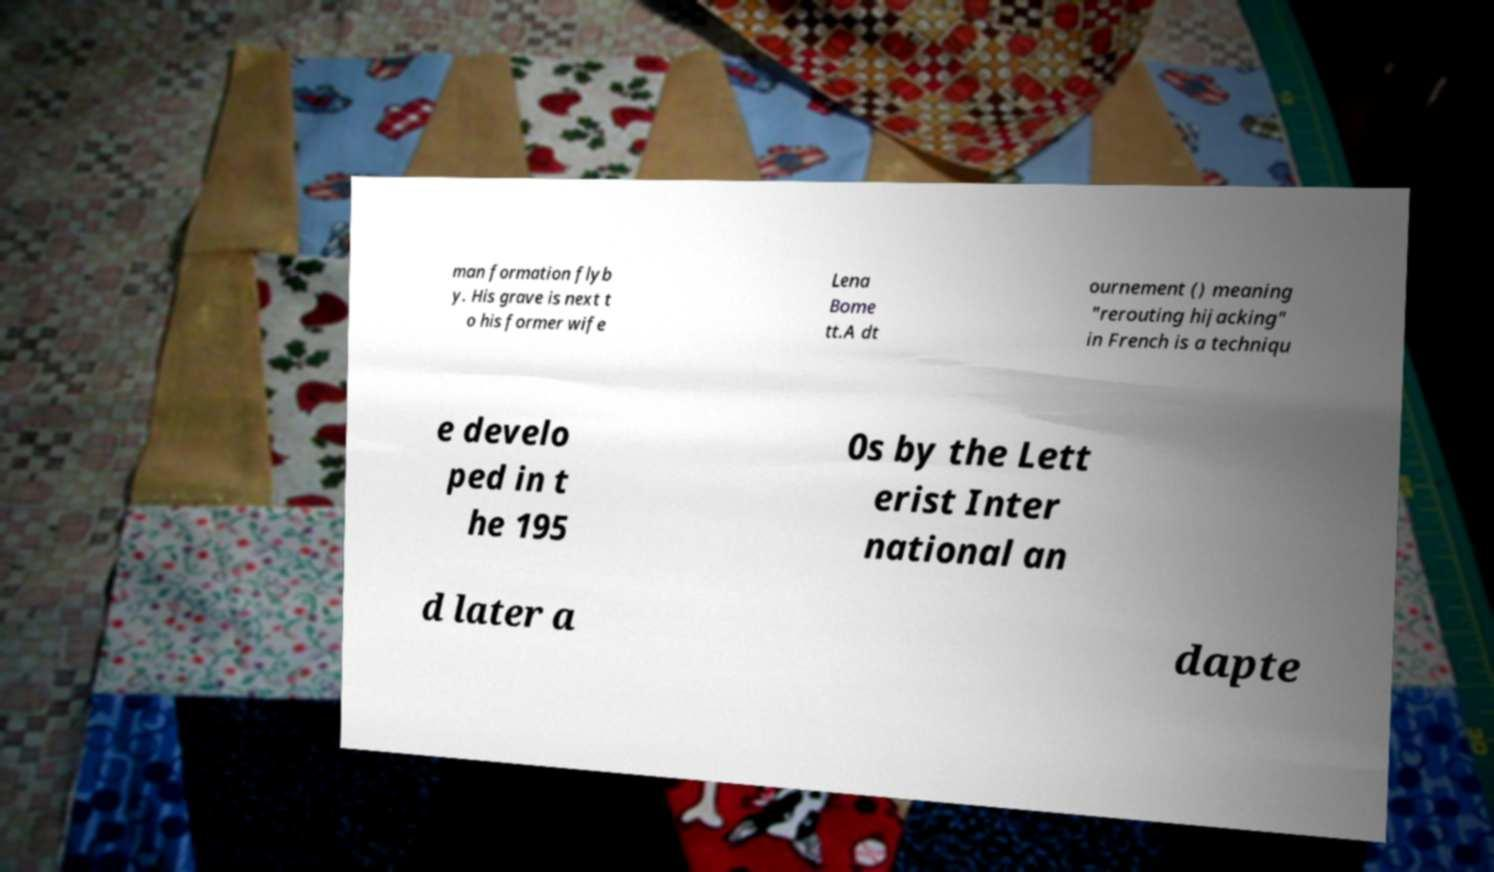What messages or text are displayed in this image? I need them in a readable, typed format. man formation flyb y. His grave is next t o his former wife Lena Bome tt.A dt ournement () meaning "rerouting hijacking" in French is a techniqu e develo ped in t he 195 0s by the Lett erist Inter national an d later a dapte 